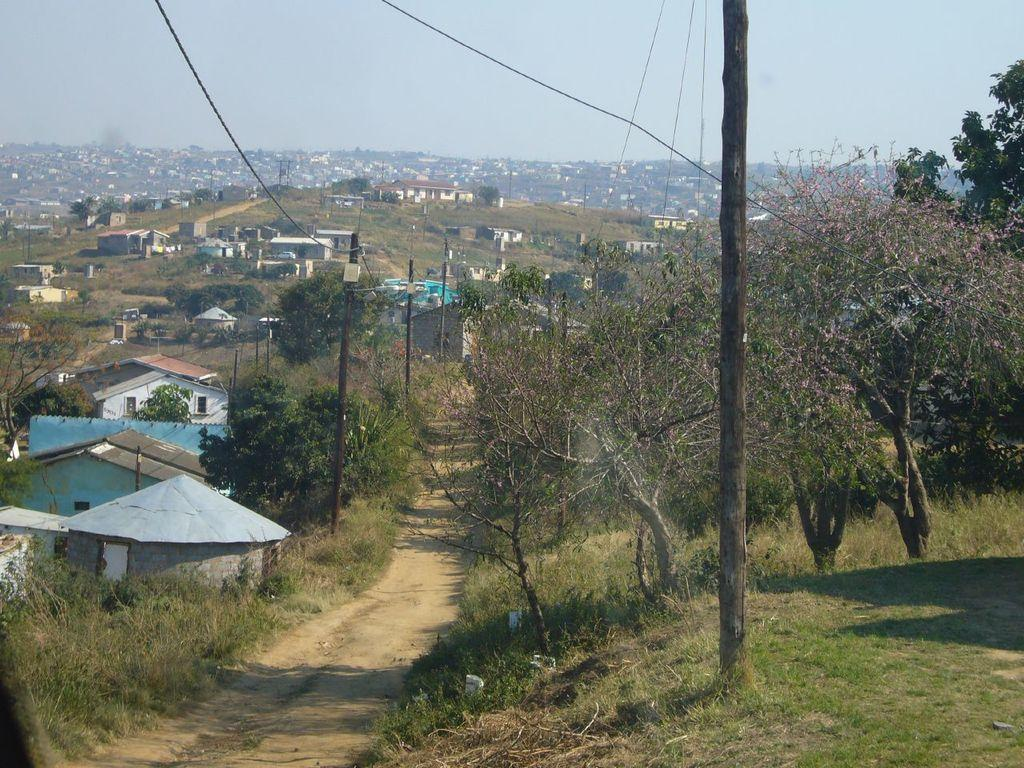What can be seen in the picture that serves as a path or way? There is a way or path in the picture. What is the ground like along the path? The ground is covered in greenery. What type of vegetation is present on either side of the path? There are trees on either side of the way. What structures can be seen in the image? There are poles visible in the image, and there are buildings in the background of the image. Can you tell me what type of order the girl is giving to the guitar in the image? There is no girl or guitar present in the image. 